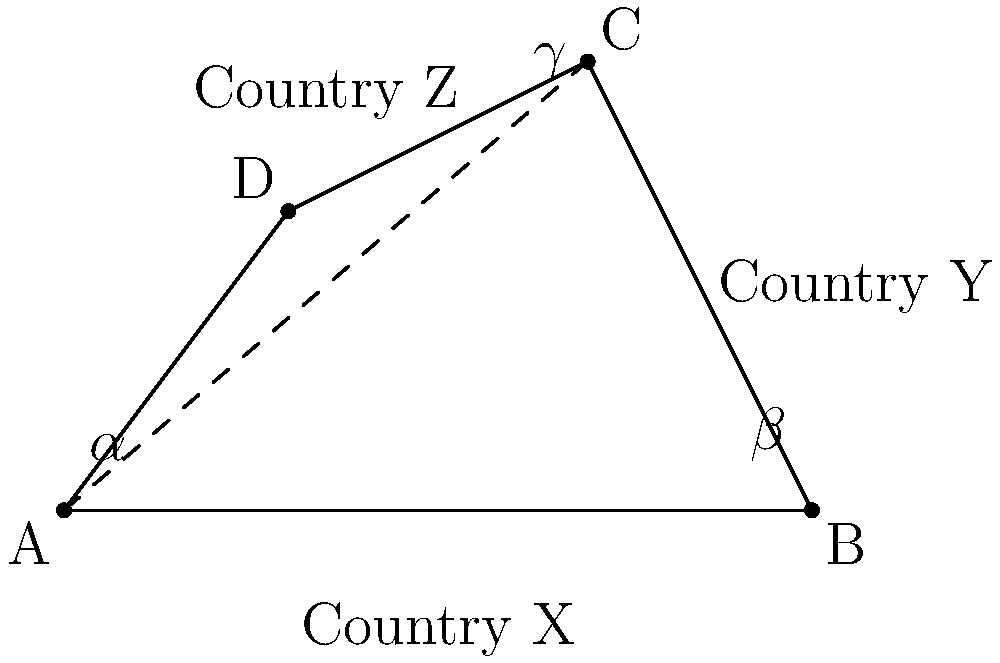In a simplified map of three bordering countries X, Y, and Z, their borders intersect to form a quadrilateral ABCD. If the interior angles of the quadrilateral at vertices A, B, and C are $\alpha$, $\beta$, and $\gamma$ respectively, and it is known that $\alpha = 60°$, $\beta = 100°$, and $\gamma = 130°$, what is the measure of the interior angle at vertex D? To solve this problem, we can use the properties of quadrilaterals:

1. In any quadrilateral, the sum of interior angles is always 360°.

2. Let's denote the unknown angle at vertex D as $\delta$.

3. We can set up an equation based on the sum of interior angles:
   $\alpha + \beta + \gamma + \delta = 360°$

4. Substitute the known values:
   $60° + 100° + 130° + \delta = 360°$

5. Simplify:
   $290° + \delta = 360°$

6. Subtract 290° from both sides:
   $\delta = 360° - 290°$

7. Calculate the result:
   $\delta = 70°$

Therefore, the measure of the interior angle at vertex D is 70°.
Answer: 70° 